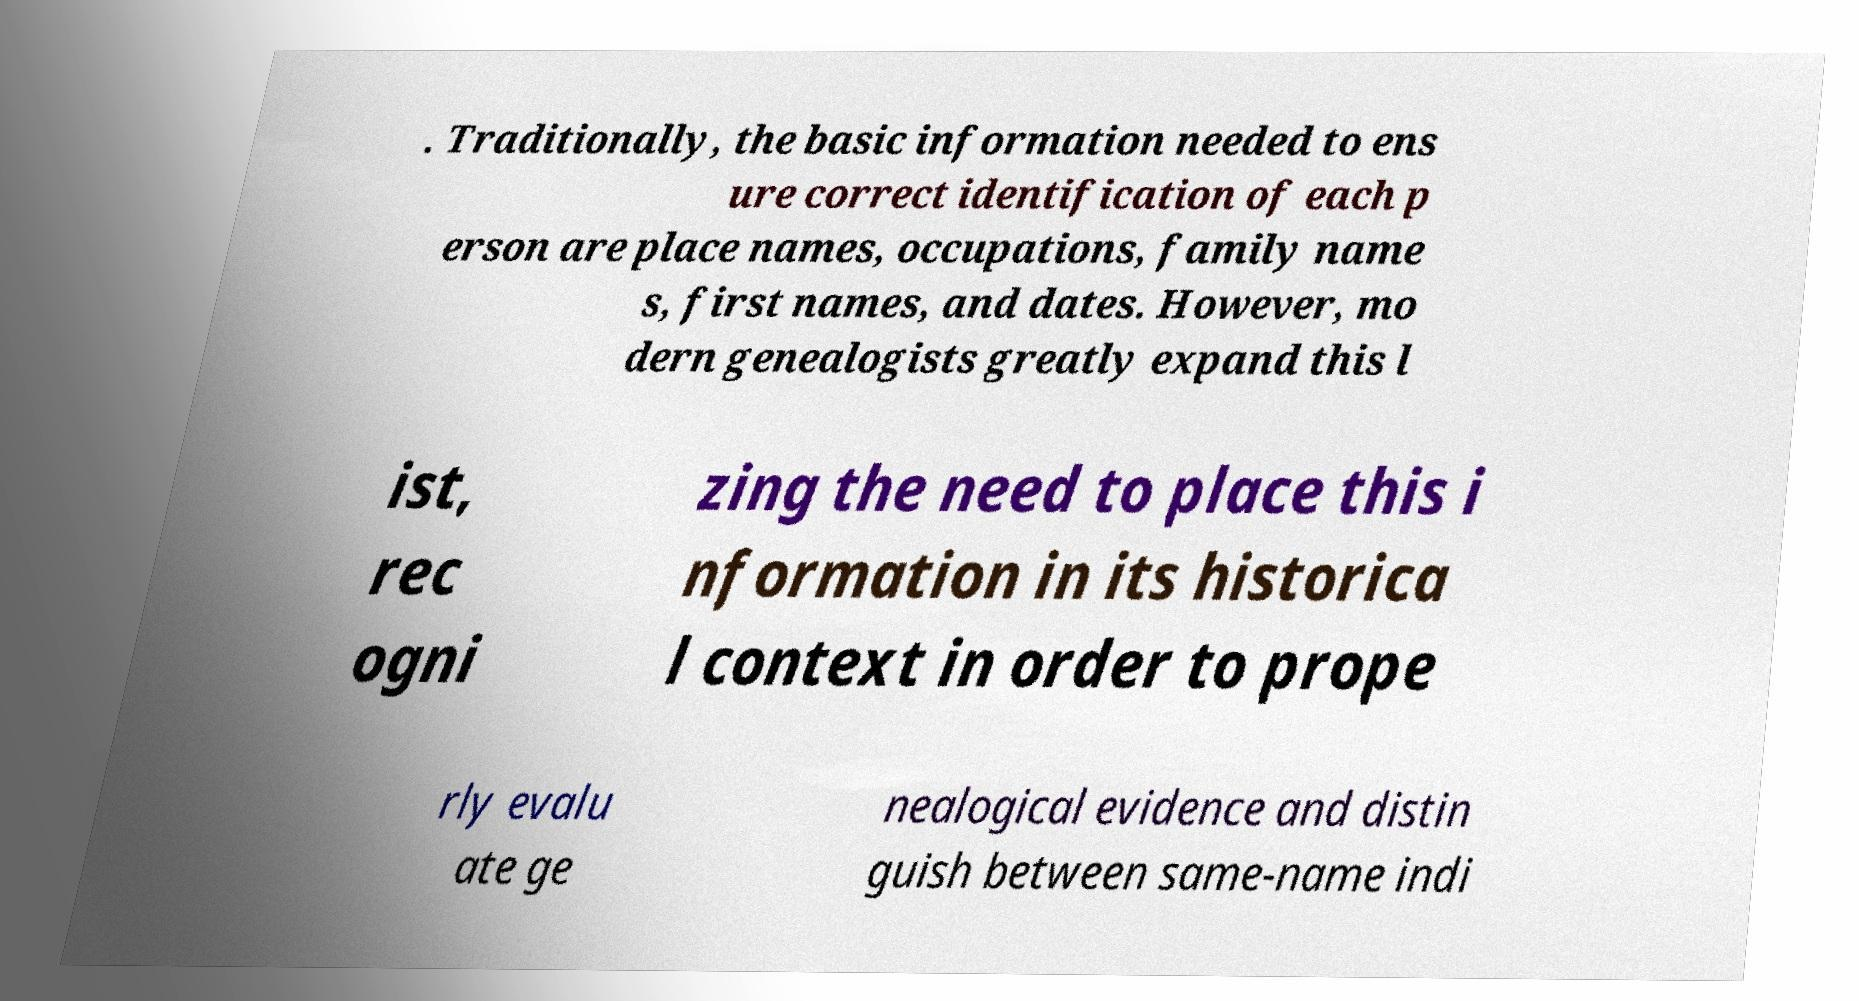There's text embedded in this image that I need extracted. Can you transcribe it verbatim? . Traditionally, the basic information needed to ens ure correct identification of each p erson are place names, occupations, family name s, first names, and dates. However, mo dern genealogists greatly expand this l ist, rec ogni zing the need to place this i nformation in its historica l context in order to prope rly evalu ate ge nealogical evidence and distin guish between same-name indi 